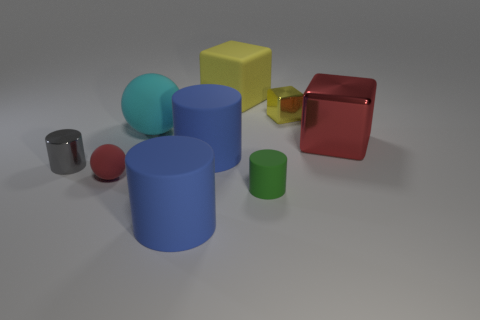There is a blue matte cylinder that is right of the big rubber cylinder in front of the green cylinder; how many red things are on the left side of it? In the scene depicted, there are no red objects positioned to the left of the blue matte cylinder. The blue cylinder is surrounded by objects of various colors, but none of them on its left side are red. 